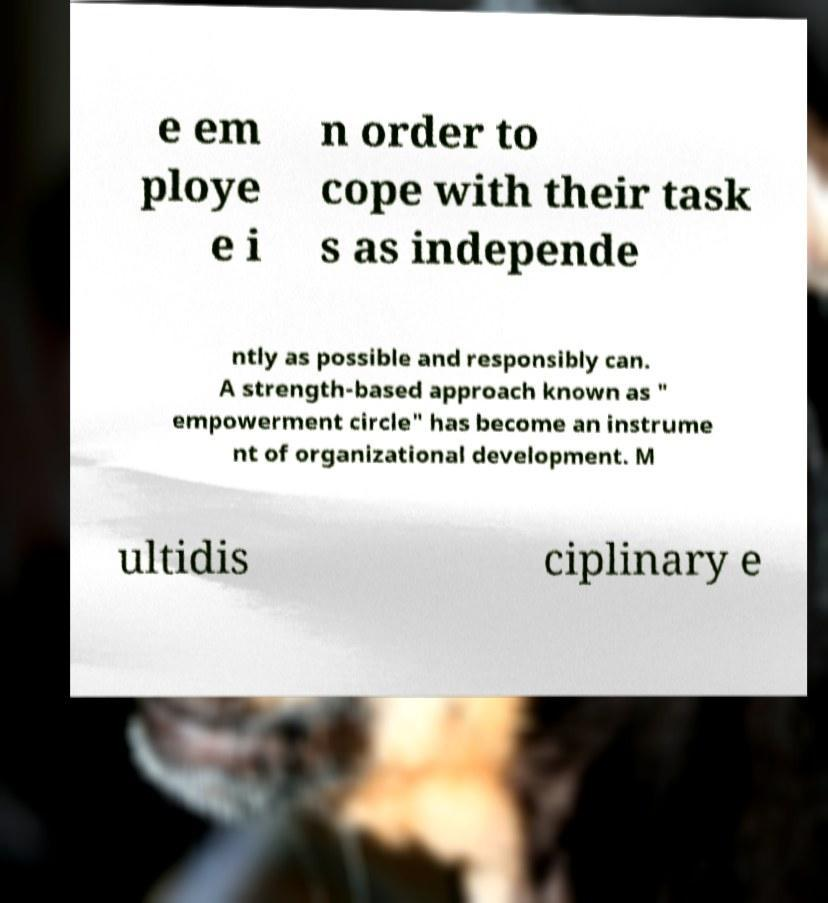Could you assist in decoding the text presented in this image and type it out clearly? e em ploye e i n order to cope with their task s as independe ntly as possible and responsibly can. A strength-based approach known as " empowerment circle" has become an instrume nt of organizational development. M ultidis ciplinary e 